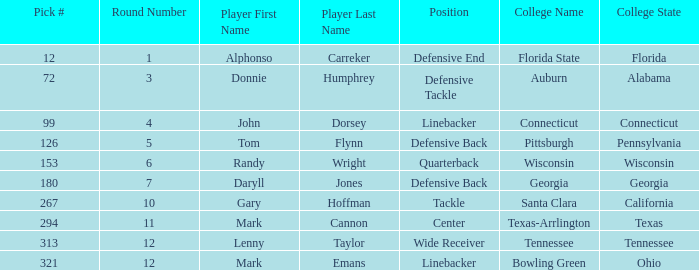Identify the player who is a wide receiver. Lenny Taylor. 